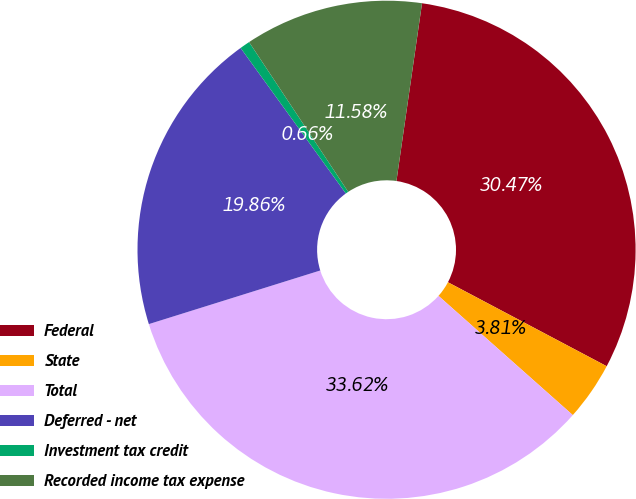<chart> <loc_0><loc_0><loc_500><loc_500><pie_chart><fcel>Federal<fcel>State<fcel>Total<fcel>Deferred - net<fcel>Investment tax credit<fcel>Recorded income tax expense<nl><fcel>30.47%<fcel>3.81%<fcel>33.62%<fcel>19.86%<fcel>0.66%<fcel>11.58%<nl></chart> 